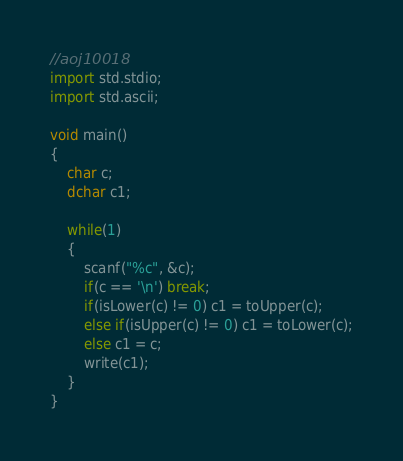Convert code to text. <code><loc_0><loc_0><loc_500><loc_500><_D_>//aoj10018
import std.stdio;
import std.ascii;

void main()
{
    char c;
    dchar c1;
    
    while(1)
    {
        scanf("%c", &c);
        if(c == '\n') break;
        if(isLower(c) != 0) c1 = toUpper(c);
        else if(isUpper(c) != 0) c1 = toLower(c);
        else c1 = c;
        write(c1);
    }
}</code> 